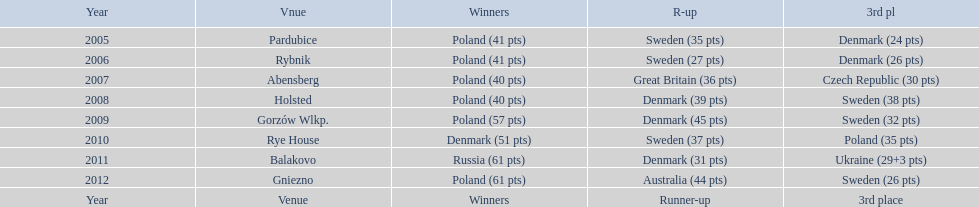Post 2008, what is the cumulative points scored by champions? 230. 